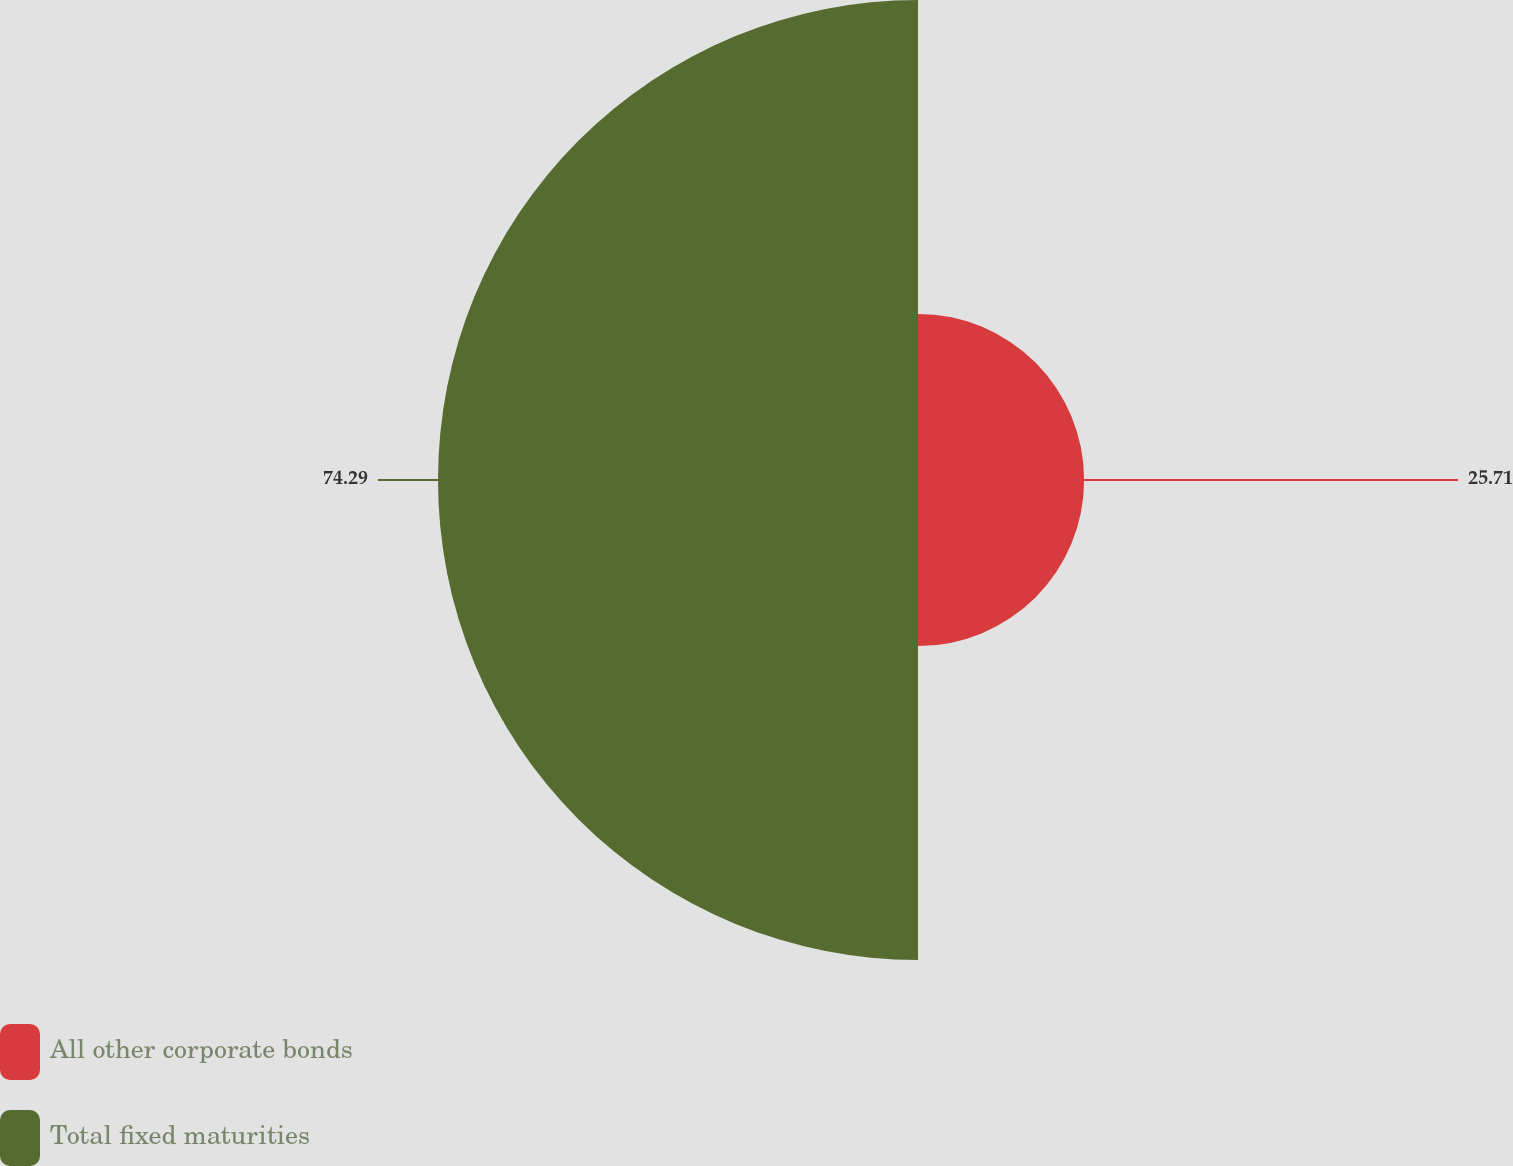<chart> <loc_0><loc_0><loc_500><loc_500><pie_chart><fcel>All other corporate bonds<fcel>Total fixed maturities<nl><fcel>25.71%<fcel>74.29%<nl></chart> 